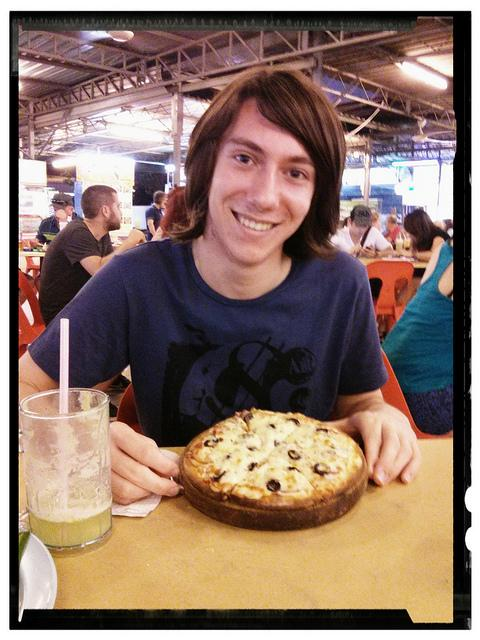What type of crust is this called? deep dish 